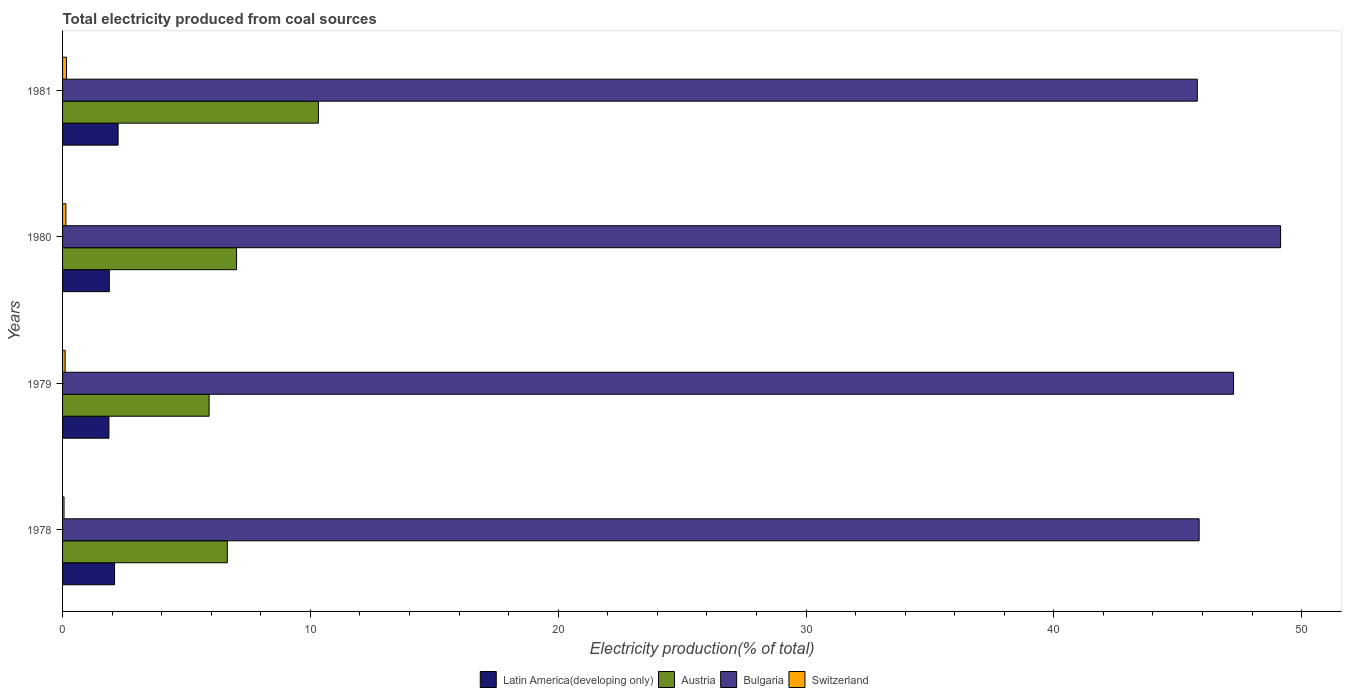Are the number of bars per tick equal to the number of legend labels?
Offer a very short reply. Yes. Are the number of bars on each tick of the Y-axis equal?
Ensure brevity in your answer.  Yes. How many bars are there on the 3rd tick from the bottom?
Make the answer very short. 4. In how many cases, is the number of bars for a given year not equal to the number of legend labels?
Your response must be concise. 0. What is the total electricity produced in Latin America(developing only) in 1979?
Ensure brevity in your answer.  1.87. Across all years, what is the maximum total electricity produced in Bulgaria?
Give a very brief answer. 49.15. Across all years, what is the minimum total electricity produced in Austria?
Offer a very short reply. 5.91. In which year was the total electricity produced in Bulgaria maximum?
Give a very brief answer. 1980. In which year was the total electricity produced in Austria minimum?
Keep it short and to the point. 1979. What is the total total electricity produced in Switzerland in the graph?
Offer a terse response. 0.46. What is the difference between the total electricity produced in Switzerland in 1978 and that in 1980?
Offer a very short reply. -0.08. What is the difference between the total electricity produced in Switzerland in 1981 and the total electricity produced in Bulgaria in 1978?
Give a very brief answer. -45.71. What is the average total electricity produced in Bulgaria per year?
Provide a succinct answer. 47.02. In the year 1981, what is the difference between the total electricity produced in Bulgaria and total electricity produced in Austria?
Provide a succinct answer. 35.47. What is the ratio of the total electricity produced in Switzerland in 1978 to that in 1981?
Your answer should be very brief. 0.37. What is the difference between the highest and the second highest total electricity produced in Austria?
Your response must be concise. 3.3. What is the difference between the highest and the lowest total electricity produced in Latin America(developing only)?
Your answer should be very brief. 0.37. Is it the case that in every year, the sum of the total electricity produced in Latin America(developing only) and total electricity produced in Bulgaria is greater than the sum of total electricity produced in Switzerland and total electricity produced in Austria?
Offer a terse response. Yes. What does the 4th bar from the top in 1980 represents?
Your answer should be very brief. Latin America(developing only). What does the 3rd bar from the bottom in 1981 represents?
Provide a short and direct response. Bulgaria. How many bars are there?
Your answer should be compact. 16. Are all the bars in the graph horizontal?
Ensure brevity in your answer.  Yes. What is the difference between two consecutive major ticks on the X-axis?
Offer a very short reply. 10. How many legend labels are there?
Your response must be concise. 4. What is the title of the graph?
Your answer should be very brief. Total electricity produced from coal sources. Does "Finland" appear as one of the legend labels in the graph?
Give a very brief answer. No. What is the label or title of the Y-axis?
Provide a short and direct response. Years. What is the Electricity production(% of total) of Latin America(developing only) in 1978?
Ensure brevity in your answer.  2.1. What is the Electricity production(% of total) in Austria in 1978?
Your response must be concise. 6.65. What is the Electricity production(% of total) in Bulgaria in 1978?
Your answer should be very brief. 45.87. What is the Electricity production(% of total) in Switzerland in 1978?
Your answer should be very brief. 0.06. What is the Electricity production(% of total) in Latin America(developing only) in 1979?
Your response must be concise. 1.87. What is the Electricity production(% of total) in Austria in 1979?
Keep it short and to the point. 5.91. What is the Electricity production(% of total) in Bulgaria in 1979?
Your response must be concise. 47.25. What is the Electricity production(% of total) in Switzerland in 1979?
Your answer should be very brief. 0.1. What is the Electricity production(% of total) in Latin America(developing only) in 1980?
Ensure brevity in your answer.  1.89. What is the Electricity production(% of total) in Austria in 1980?
Offer a terse response. 7.02. What is the Electricity production(% of total) in Bulgaria in 1980?
Your response must be concise. 49.15. What is the Electricity production(% of total) of Switzerland in 1980?
Your answer should be compact. 0.13. What is the Electricity production(% of total) in Latin America(developing only) in 1981?
Your answer should be compact. 2.24. What is the Electricity production(% of total) in Austria in 1981?
Offer a very short reply. 10.32. What is the Electricity production(% of total) in Bulgaria in 1981?
Ensure brevity in your answer.  45.79. What is the Electricity production(% of total) of Switzerland in 1981?
Offer a very short reply. 0.16. Across all years, what is the maximum Electricity production(% of total) in Latin America(developing only)?
Provide a succinct answer. 2.24. Across all years, what is the maximum Electricity production(% of total) in Austria?
Make the answer very short. 10.32. Across all years, what is the maximum Electricity production(% of total) in Bulgaria?
Provide a succinct answer. 49.15. Across all years, what is the maximum Electricity production(% of total) in Switzerland?
Provide a succinct answer. 0.16. Across all years, what is the minimum Electricity production(% of total) of Latin America(developing only)?
Make the answer very short. 1.87. Across all years, what is the minimum Electricity production(% of total) in Austria?
Make the answer very short. 5.91. Across all years, what is the minimum Electricity production(% of total) of Bulgaria?
Give a very brief answer. 45.79. Across all years, what is the minimum Electricity production(% of total) of Switzerland?
Your answer should be compact. 0.06. What is the total Electricity production(% of total) in Latin America(developing only) in the graph?
Your response must be concise. 8.1. What is the total Electricity production(% of total) in Austria in the graph?
Keep it short and to the point. 29.91. What is the total Electricity production(% of total) in Bulgaria in the graph?
Offer a very short reply. 188.06. What is the total Electricity production(% of total) in Switzerland in the graph?
Provide a short and direct response. 0.46. What is the difference between the Electricity production(% of total) of Latin America(developing only) in 1978 and that in 1979?
Your answer should be compact. 0.23. What is the difference between the Electricity production(% of total) of Austria in 1978 and that in 1979?
Your answer should be compact. 0.74. What is the difference between the Electricity production(% of total) in Bulgaria in 1978 and that in 1979?
Your answer should be very brief. -1.39. What is the difference between the Electricity production(% of total) in Switzerland in 1978 and that in 1979?
Provide a short and direct response. -0.04. What is the difference between the Electricity production(% of total) of Latin America(developing only) in 1978 and that in 1980?
Offer a terse response. 0.21. What is the difference between the Electricity production(% of total) in Austria in 1978 and that in 1980?
Provide a short and direct response. -0.37. What is the difference between the Electricity production(% of total) of Bulgaria in 1978 and that in 1980?
Keep it short and to the point. -3.29. What is the difference between the Electricity production(% of total) of Switzerland in 1978 and that in 1980?
Offer a terse response. -0.08. What is the difference between the Electricity production(% of total) in Latin America(developing only) in 1978 and that in 1981?
Make the answer very short. -0.14. What is the difference between the Electricity production(% of total) in Austria in 1978 and that in 1981?
Make the answer very short. -3.67. What is the difference between the Electricity production(% of total) of Bulgaria in 1978 and that in 1981?
Your answer should be very brief. 0.07. What is the difference between the Electricity production(% of total) in Switzerland in 1978 and that in 1981?
Ensure brevity in your answer.  -0.1. What is the difference between the Electricity production(% of total) of Latin America(developing only) in 1979 and that in 1980?
Provide a succinct answer. -0.02. What is the difference between the Electricity production(% of total) in Austria in 1979 and that in 1980?
Provide a short and direct response. -1.11. What is the difference between the Electricity production(% of total) in Bulgaria in 1979 and that in 1980?
Make the answer very short. -1.9. What is the difference between the Electricity production(% of total) of Switzerland in 1979 and that in 1980?
Give a very brief answer. -0.03. What is the difference between the Electricity production(% of total) in Latin America(developing only) in 1979 and that in 1981?
Your response must be concise. -0.37. What is the difference between the Electricity production(% of total) in Austria in 1979 and that in 1981?
Provide a short and direct response. -4.41. What is the difference between the Electricity production(% of total) of Bulgaria in 1979 and that in 1981?
Your answer should be compact. 1.46. What is the difference between the Electricity production(% of total) in Switzerland in 1979 and that in 1981?
Ensure brevity in your answer.  -0.06. What is the difference between the Electricity production(% of total) of Latin America(developing only) in 1980 and that in 1981?
Make the answer very short. -0.36. What is the difference between the Electricity production(% of total) of Austria in 1980 and that in 1981?
Give a very brief answer. -3.3. What is the difference between the Electricity production(% of total) of Bulgaria in 1980 and that in 1981?
Your response must be concise. 3.36. What is the difference between the Electricity production(% of total) of Switzerland in 1980 and that in 1981?
Keep it short and to the point. -0.03. What is the difference between the Electricity production(% of total) of Latin America(developing only) in 1978 and the Electricity production(% of total) of Austria in 1979?
Offer a very short reply. -3.81. What is the difference between the Electricity production(% of total) in Latin America(developing only) in 1978 and the Electricity production(% of total) in Bulgaria in 1979?
Ensure brevity in your answer.  -45.15. What is the difference between the Electricity production(% of total) of Latin America(developing only) in 1978 and the Electricity production(% of total) of Switzerland in 1979?
Provide a succinct answer. 2. What is the difference between the Electricity production(% of total) of Austria in 1978 and the Electricity production(% of total) of Bulgaria in 1979?
Your response must be concise. -40.6. What is the difference between the Electricity production(% of total) in Austria in 1978 and the Electricity production(% of total) in Switzerland in 1979?
Ensure brevity in your answer.  6.55. What is the difference between the Electricity production(% of total) in Bulgaria in 1978 and the Electricity production(% of total) in Switzerland in 1979?
Your answer should be very brief. 45.76. What is the difference between the Electricity production(% of total) of Latin America(developing only) in 1978 and the Electricity production(% of total) of Austria in 1980?
Offer a very short reply. -4.92. What is the difference between the Electricity production(% of total) of Latin America(developing only) in 1978 and the Electricity production(% of total) of Bulgaria in 1980?
Make the answer very short. -47.05. What is the difference between the Electricity production(% of total) in Latin America(developing only) in 1978 and the Electricity production(% of total) in Switzerland in 1980?
Offer a terse response. 1.96. What is the difference between the Electricity production(% of total) of Austria in 1978 and the Electricity production(% of total) of Bulgaria in 1980?
Your answer should be compact. -42.5. What is the difference between the Electricity production(% of total) of Austria in 1978 and the Electricity production(% of total) of Switzerland in 1980?
Offer a terse response. 6.51. What is the difference between the Electricity production(% of total) in Bulgaria in 1978 and the Electricity production(% of total) in Switzerland in 1980?
Your answer should be compact. 45.73. What is the difference between the Electricity production(% of total) of Latin America(developing only) in 1978 and the Electricity production(% of total) of Austria in 1981?
Offer a very short reply. -8.22. What is the difference between the Electricity production(% of total) of Latin America(developing only) in 1978 and the Electricity production(% of total) of Bulgaria in 1981?
Keep it short and to the point. -43.69. What is the difference between the Electricity production(% of total) in Latin America(developing only) in 1978 and the Electricity production(% of total) in Switzerland in 1981?
Keep it short and to the point. 1.94. What is the difference between the Electricity production(% of total) in Austria in 1978 and the Electricity production(% of total) in Bulgaria in 1981?
Give a very brief answer. -39.14. What is the difference between the Electricity production(% of total) of Austria in 1978 and the Electricity production(% of total) of Switzerland in 1981?
Make the answer very short. 6.49. What is the difference between the Electricity production(% of total) of Bulgaria in 1978 and the Electricity production(% of total) of Switzerland in 1981?
Ensure brevity in your answer.  45.71. What is the difference between the Electricity production(% of total) in Latin America(developing only) in 1979 and the Electricity production(% of total) in Austria in 1980?
Your response must be concise. -5.15. What is the difference between the Electricity production(% of total) in Latin America(developing only) in 1979 and the Electricity production(% of total) in Bulgaria in 1980?
Offer a very short reply. -47.28. What is the difference between the Electricity production(% of total) in Latin America(developing only) in 1979 and the Electricity production(% of total) in Switzerland in 1980?
Make the answer very short. 1.74. What is the difference between the Electricity production(% of total) of Austria in 1979 and the Electricity production(% of total) of Bulgaria in 1980?
Keep it short and to the point. -43.24. What is the difference between the Electricity production(% of total) in Austria in 1979 and the Electricity production(% of total) in Switzerland in 1980?
Make the answer very short. 5.78. What is the difference between the Electricity production(% of total) in Bulgaria in 1979 and the Electricity production(% of total) in Switzerland in 1980?
Ensure brevity in your answer.  47.12. What is the difference between the Electricity production(% of total) in Latin America(developing only) in 1979 and the Electricity production(% of total) in Austria in 1981?
Ensure brevity in your answer.  -8.45. What is the difference between the Electricity production(% of total) in Latin America(developing only) in 1979 and the Electricity production(% of total) in Bulgaria in 1981?
Your answer should be very brief. -43.92. What is the difference between the Electricity production(% of total) of Latin America(developing only) in 1979 and the Electricity production(% of total) of Switzerland in 1981?
Provide a succinct answer. 1.71. What is the difference between the Electricity production(% of total) in Austria in 1979 and the Electricity production(% of total) in Bulgaria in 1981?
Offer a very short reply. -39.88. What is the difference between the Electricity production(% of total) in Austria in 1979 and the Electricity production(% of total) in Switzerland in 1981?
Make the answer very short. 5.75. What is the difference between the Electricity production(% of total) in Bulgaria in 1979 and the Electricity production(% of total) in Switzerland in 1981?
Provide a short and direct response. 47.09. What is the difference between the Electricity production(% of total) in Latin America(developing only) in 1980 and the Electricity production(% of total) in Austria in 1981?
Give a very brief answer. -8.44. What is the difference between the Electricity production(% of total) in Latin America(developing only) in 1980 and the Electricity production(% of total) in Bulgaria in 1981?
Provide a short and direct response. -43.91. What is the difference between the Electricity production(% of total) in Latin America(developing only) in 1980 and the Electricity production(% of total) in Switzerland in 1981?
Your answer should be very brief. 1.73. What is the difference between the Electricity production(% of total) in Austria in 1980 and the Electricity production(% of total) in Bulgaria in 1981?
Your answer should be very brief. -38.77. What is the difference between the Electricity production(% of total) in Austria in 1980 and the Electricity production(% of total) in Switzerland in 1981?
Give a very brief answer. 6.86. What is the difference between the Electricity production(% of total) in Bulgaria in 1980 and the Electricity production(% of total) in Switzerland in 1981?
Ensure brevity in your answer.  48.99. What is the average Electricity production(% of total) of Latin America(developing only) per year?
Offer a very short reply. 2.02. What is the average Electricity production(% of total) in Austria per year?
Ensure brevity in your answer.  7.48. What is the average Electricity production(% of total) of Bulgaria per year?
Provide a short and direct response. 47.02. What is the average Electricity production(% of total) of Switzerland per year?
Ensure brevity in your answer.  0.11. In the year 1978, what is the difference between the Electricity production(% of total) in Latin America(developing only) and Electricity production(% of total) in Austria?
Your answer should be compact. -4.55. In the year 1978, what is the difference between the Electricity production(% of total) of Latin America(developing only) and Electricity production(% of total) of Bulgaria?
Make the answer very short. -43.77. In the year 1978, what is the difference between the Electricity production(% of total) of Latin America(developing only) and Electricity production(% of total) of Switzerland?
Provide a succinct answer. 2.04. In the year 1978, what is the difference between the Electricity production(% of total) of Austria and Electricity production(% of total) of Bulgaria?
Offer a very short reply. -39.22. In the year 1978, what is the difference between the Electricity production(% of total) in Austria and Electricity production(% of total) in Switzerland?
Provide a succinct answer. 6.59. In the year 1978, what is the difference between the Electricity production(% of total) of Bulgaria and Electricity production(% of total) of Switzerland?
Provide a short and direct response. 45.81. In the year 1979, what is the difference between the Electricity production(% of total) of Latin America(developing only) and Electricity production(% of total) of Austria?
Keep it short and to the point. -4.04. In the year 1979, what is the difference between the Electricity production(% of total) of Latin America(developing only) and Electricity production(% of total) of Bulgaria?
Your answer should be compact. -45.38. In the year 1979, what is the difference between the Electricity production(% of total) in Latin America(developing only) and Electricity production(% of total) in Switzerland?
Your answer should be very brief. 1.77. In the year 1979, what is the difference between the Electricity production(% of total) in Austria and Electricity production(% of total) in Bulgaria?
Make the answer very short. -41.34. In the year 1979, what is the difference between the Electricity production(% of total) in Austria and Electricity production(% of total) in Switzerland?
Provide a short and direct response. 5.81. In the year 1979, what is the difference between the Electricity production(% of total) of Bulgaria and Electricity production(% of total) of Switzerland?
Offer a very short reply. 47.15. In the year 1980, what is the difference between the Electricity production(% of total) of Latin America(developing only) and Electricity production(% of total) of Austria?
Your answer should be very brief. -5.14. In the year 1980, what is the difference between the Electricity production(% of total) in Latin America(developing only) and Electricity production(% of total) in Bulgaria?
Provide a succinct answer. -47.27. In the year 1980, what is the difference between the Electricity production(% of total) in Latin America(developing only) and Electricity production(% of total) in Switzerland?
Give a very brief answer. 1.75. In the year 1980, what is the difference between the Electricity production(% of total) in Austria and Electricity production(% of total) in Bulgaria?
Ensure brevity in your answer.  -42.13. In the year 1980, what is the difference between the Electricity production(% of total) in Austria and Electricity production(% of total) in Switzerland?
Your answer should be compact. 6.89. In the year 1980, what is the difference between the Electricity production(% of total) of Bulgaria and Electricity production(% of total) of Switzerland?
Keep it short and to the point. 49.02. In the year 1981, what is the difference between the Electricity production(% of total) in Latin America(developing only) and Electricity production(% of total) in Austria?
Your answer should be compact. -8.08. In the year 1981, what is the difference between the Electricity production(% of total) in Latin America(developing only) and Electricity production(% of total) in Bulgaria?
Your answer should be very brief. -43.55. In the year 1981, what is the difference between the Electricity production(% of total) of Latin America(developing only) and Electricity production(% of total) of Switzerland?
Provide a short and direct response. 2.08. In the year 1981, what is the difference between the Electricity production(% of total) in Austria and Electricity production(% of total) in Bulgaria?
Give a very brief answer. -35.47. In the year 1981, what is the difference between the Electricity production(% of total) in Austria and Electricity production(% of total) in Switzerland?
Provide a succinct answer. 10.16. In the year 1981, what is the difference between the Electricity production(% of total) in Bulgaria and Electricity production(% of total) in Switzerland?
Offer a terse response. 45.63. What is the ratio of the Electricity production(% of total) of Latin America(developing only) in 1978 to that in 1979?
Ensure brevity in your answer.  1.12. What is the ratio of the Electricity production(% of total) in Austria in 1978 to that in 1979?
Your answer should be compact. 1.12. What is the ratio of the Electricity production(% of total) in Bulgaria in 1978 to that in 1979?
Provide a short and direct response. 0.97. What is the ratio of the Electricity production(% of total) in Switzerland in 1978 to that in 1979?
Offer a terse response. 0.57. What is the ratio of the Electricity production(% of total) in Latin America(developing only) in 1978 to that in 1980?
Ensure brevity in your answer.  1.11. What is the ratio of the Electricity production(% of total) in Austria in 1978 to that in 1980?
Offer a terse response. 0.95. What is the ratio of the Electricity production(% of total) of Bulgaria in 1978 to that in 1980?
Your response must be concise. 0.93. What is the ratio of the Electricity production(% of total) in Switzerland in 1978 to that in 1980?
Offer a terse response. 0.44. What is the ratio of the Electricity production(% of total) of Latin America(developing only) in 1978 to that in 1981?
Your answer should be compact. 0.94. What is the ratio of the Electricity production(% of total) in Austria in 1978 to that in 1981?
Offer a terse response. 0.64. What is the ratio of the Electricity production(% of total) of Switzerland in 1978 to that in 1981?
Give a very brief answer. 0.37. What is the ratio of the Electricity production(% of total) of Latin America(developing only) in 1979 to that in 1980?
Ensure brevity in your answer.  0.99. What is the ratio of the Electricity production(% of total) in Austria in 1979 to that in 1980?
Provide a short and direct response. 0.84. What is the ratio of the Electricity production(% of total) in Bulgaria in 1979 to that in 1980?
Make the answer very short. 0.96. What is the ratio of the Electricity production(% of total) of Switzerland in 1979 to that in 1980?
Provide a short and direct response. 0.77. What is the ratio of the Electricity production(% of total) of Latin America(developing only) in 1979 to that in 1981?
Your answer should be very brief. 0.83. What is the ratio of the Electricity production(% of total) of Austria in 1979 to that in 1981?
Ensure brevity in your answer.  0.57. What is the ratio of the Electricity production(% of total) of Bulgaria in 1979 to that in 1981?
Your response must be concise. 1.03. What is the ratio of the Electricity production(% of total) in Switzerland in 1979 to that in 1981?
Offer a very short reply. 0.65. What is the ratio of the Electricity production(% of total) in Latin America(developing only) in 1980 to that in 1981?
Offer a very short reply. 0.84. What is the ratio of the Electricity production(% of total) of Austria in 1980 to that in 1981?
Your answer should be very brief. 0.68. What is the ratio of the Electricity production(% of total) in Bulgaria in 1980 to that in 1981?
Offer a very short reply. 1.07. What is the ratio of the Electricity production(% of total) of Switzerland in 1980 to that in 1981?
Your response must be concise. 0.84. What is the difference between the highest and the second highest Electricity production(% of total) of Latin America(developing only)?
Your answer should be very brief. 0.14. What is the difference between the highest and the second highest Electricity production(% of total) in Austria?
Your answer should be very brief. 3.3. What is the difference between the highest and the second highest Electricity production(% of total) of Bulgaria?
Keep it short and to the point. 1.9. What is the difference between the highest and the second highest Electricity production(% of total) in Switzerland?
Offer a very short reply. 0.03. What is the difference between the highest and the lowest Electricity production(% of total) in Latin America(developing only)?
Your answer should be very brief. 0.37. What is the difference between the highest and the lowest Electricity production(% of total) in Austria?
Your response must be concise. 4.41. What is the difference between the highest and the lowest Electricity production(% of total) in Bulgaria?
Provide a short and direct response. 3.36. What is the difference between the highest and the lowest Electricity production(% of total) in Switzerland?
Your response must be concise. 0.1. 